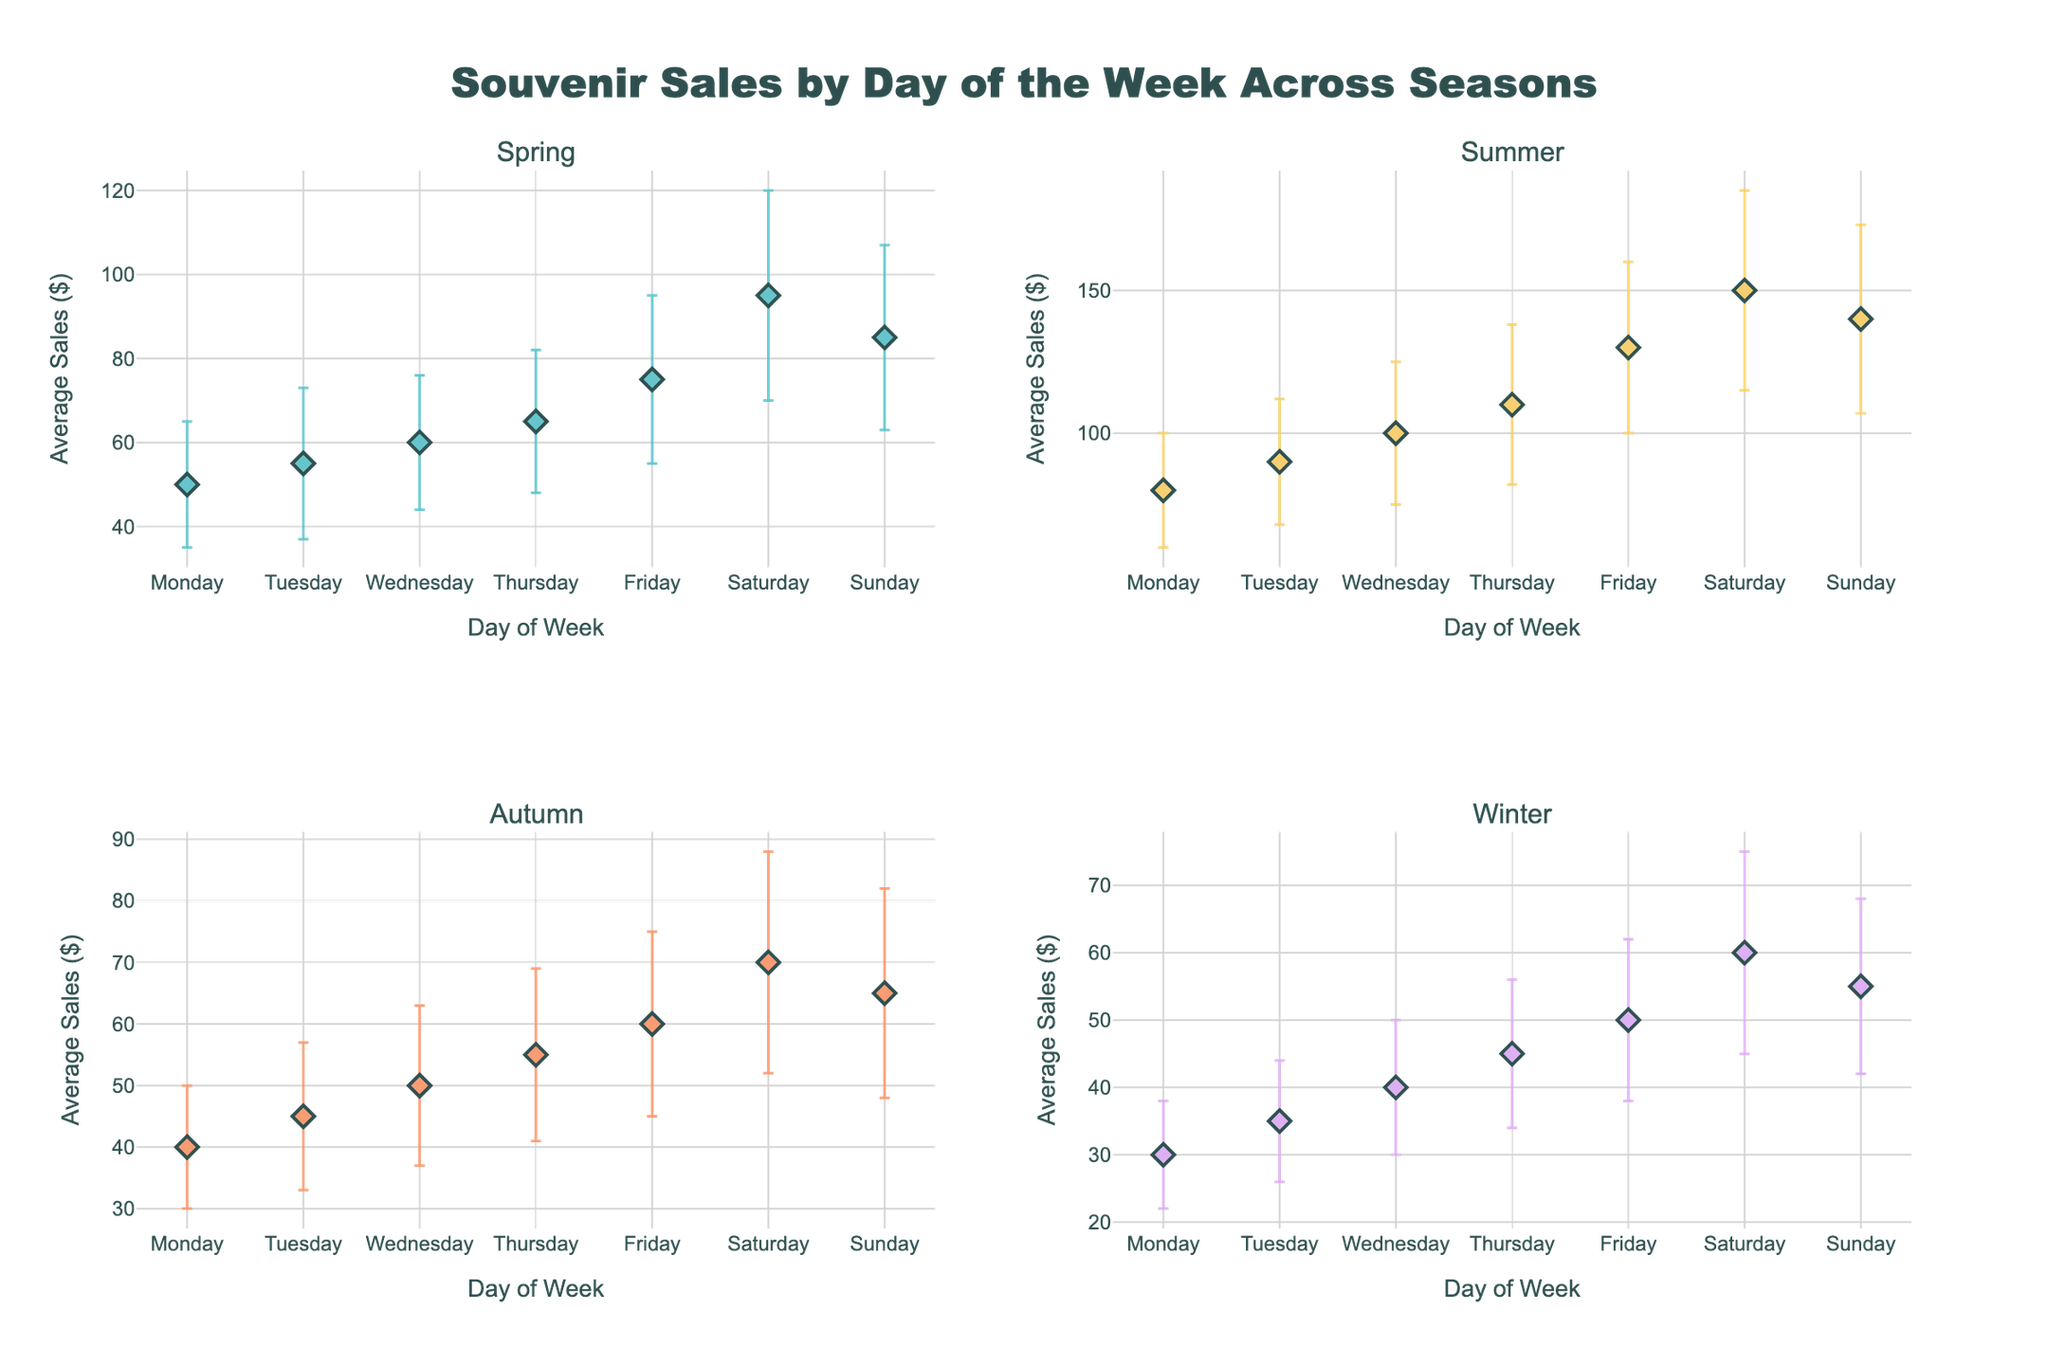What is the title of the figure? The title is given at the top of the figure and it states the overall theme or subject.
Answer: Souvenir Sales by Day of the Week Across Seasons Which day of the week has the highest average sales in Summer? Look at the data points for Summer and identify the highest average sales on the y-axis.
Answer: Saturday Which season shows the least variation in sales for Thursday? Compare the length of the error bars for Thursday across all seasons and see which one has the shortest.
Answer: Winter By how much do the average sales on Tuesday in Autumn exceed those on Monday in Winter? Find and subtract the average sales for Tuesday in Autumn and Monday in Winter, referring to the figure for the values. Average sales on Tuesday in Autumn = 45, and on Monday in Winter = 30. So, 45 - 30 = 15.
Answer: 15 On which day is the sales variability highest in Spring? Look for the longest error bar in Spring for different days of the week.
Answer: Saturday Which day of the week shows the biggest difference in average sales between Spring and Winter? Calculate the differences in average sales for each day between Spring and Winter, and identify the day with the largest difference. e.g., Monday: 50 - 30 = 20, Tuesday: 55 - 35 = 20... the largest is for Sunday: 85 - 55 = 30.
Answer: Sunday What is the average sales value on Wednesdays in Summer? Check the y-axis value for the Wednesdays data point in Summer.
Answer: 100 How do the average sales on Friday in Autumn compare to those on Wednesday in Winter? Compare the y-values for Friday in Autumn and Wednesday in Winter directly from the figure.
Answer: 10 higher for Autumn What's the range of average sales values for Saturday across all seasons? Find the highest and lowest average sales for Saturday in all seasons, and then subtract the smallest value from the largest. Highest: Summer (150), Lowest: Winter (60). So, 150 - 60 = 90.
Answer: 90 What day exhibits the least variability in Winter? Look at the error bars for Winter across all days, focusing on which is the shortest.
Answer: Monday 